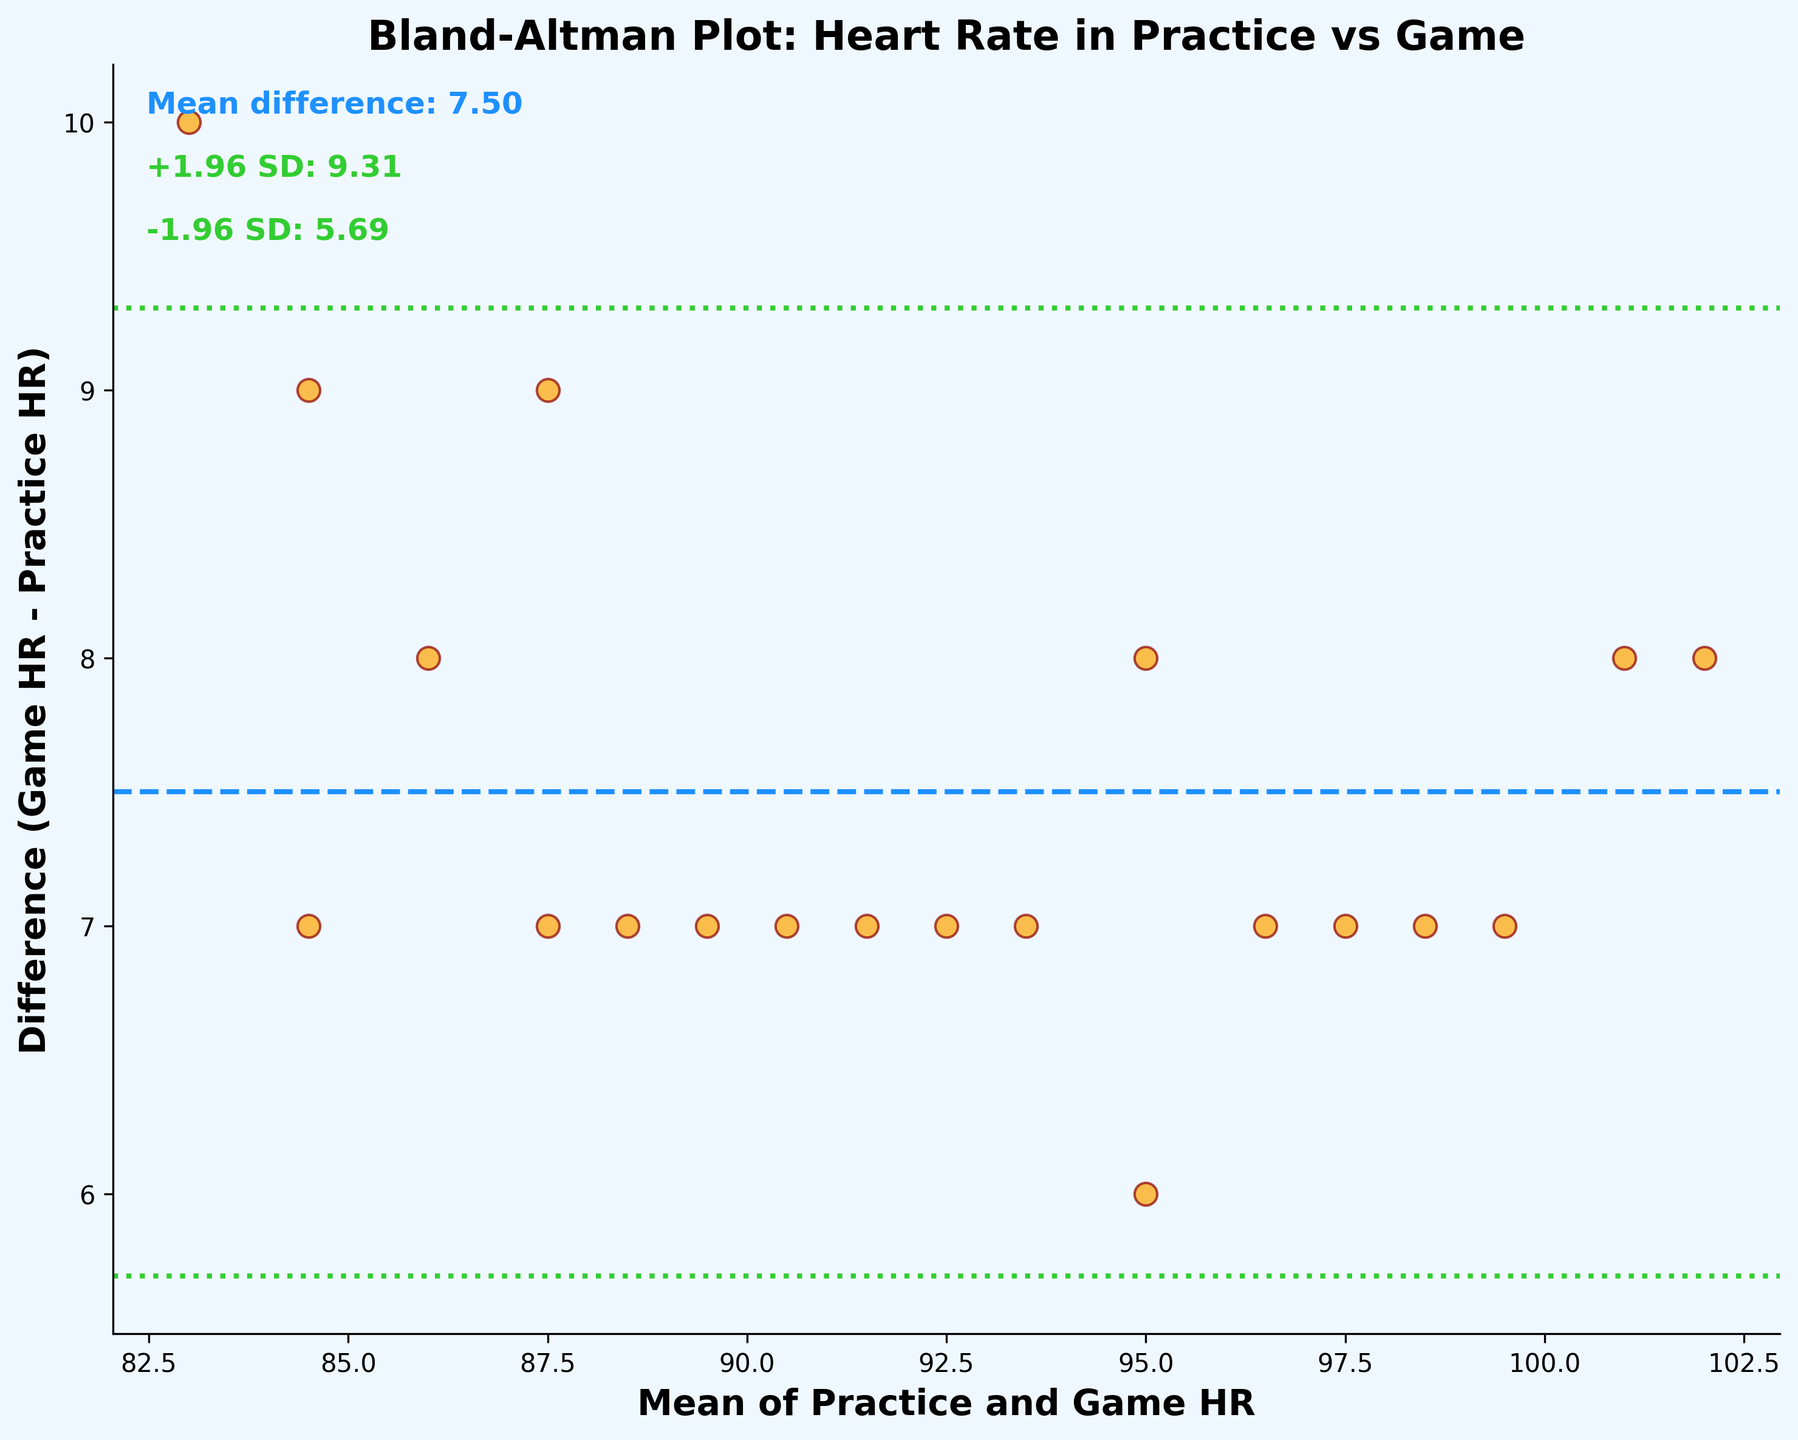How many data points are plotted on the figure? Count the number of orange scatter points on the plot. There are 20 pairs of heart rate measurements, so there should be 20 points.
Answer: 20 What's the title of the plot? The plot has a text at the top which states the title. Look for words in a larger, bold font at the top of the plot.
Answer: Bland-Altman Plot: Heart Rate in Practice vs Game What is the label of the x-axis? The label is written below the horizontal axis, identifying what the x-axis represents. It's in a larger, bold font.
Answer: Mean of Practice and Game HR What are the upper and lower limits of agreement? These limits are shown as dotted green lines above and below the mean difference line. The exact values are normally annotated near these lines.
Answer: Upper: 14.66, Lower: -1.66 Which heart rate condition has higher variability: practice or game? Assess the spread of the differences relative to the x-axis. If differences are consistently larger, the variability in game measurement tends to be higher.
Answer: Game Is there any systematic bias observed between practice and game heart rates? Look at the general trend of the points around the mean difference line. If most points are above or below this line, there is a bias.
Answer: Yes, the game HR tends to be higher What does a point with a positive y-value indicate? A positive y-value on the Bland-Altman plot means that the game heart rate is higher than the practice heart rate for that data point, as indicated by the y-axis representing 'Difference (Game HR - Practice HR)'.
Answer: Game HR > Practice HR For the data point with the highest mean heart rate, what is the corresponding difference in heart rates? Identify the point farthest to the right on the x-axis and read the y-value of this point. The mean value (x-axis) is the highest heart rate, and the y-value will give the difference.
Answer: Difference is 8 